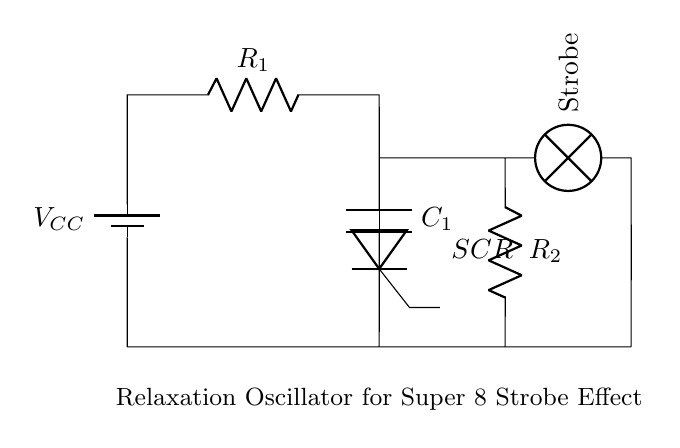What is the voltage source in this circuit? The voltage source is labeled as V_C_C, which represents the power supply for the circuit.
Answer: V_C_C What is the role of the capacitor in this circuit? The capacitor, labeled C_1, stores energy and is responsible for timing in the oscillator circuit, leading to the strobe effect when it discharges.
Answer: Timing How many resistors are in this circuit? There are two resistors present, labeled R_1 and R_2, which are essential for defining the charge and discharge rates in the oscillator.
Answer: Two What component is controlling the discharge of the capacitor? The component controlling the discharge is a thyristor, labeled SCR, which allows current to flow through after detecting a specific voltage.
Answer: SCR How does the strobe light activate in this circuit? The strobe light activates when the capacitor C_1 discharges through the SCR, which typically occurs at intervals determined by R_1, C_1, and R_2, producing the strobe effect.
Answer: Capacitor discharge What is the purpose of resistor R_2 in the circuit? Resistor R_2 is used to limit the current flowing through the strobe lamp when it turns on, preventing potential damage to the lamp.
Answer: Current limiting What type of oscillator is represented by this circuit? This circuit is identified as a relaxation oscillator, which uses the charging and discharging of a capacitor to create an oscillating output suitable for strobe light effects.
Answer: Relaxation 